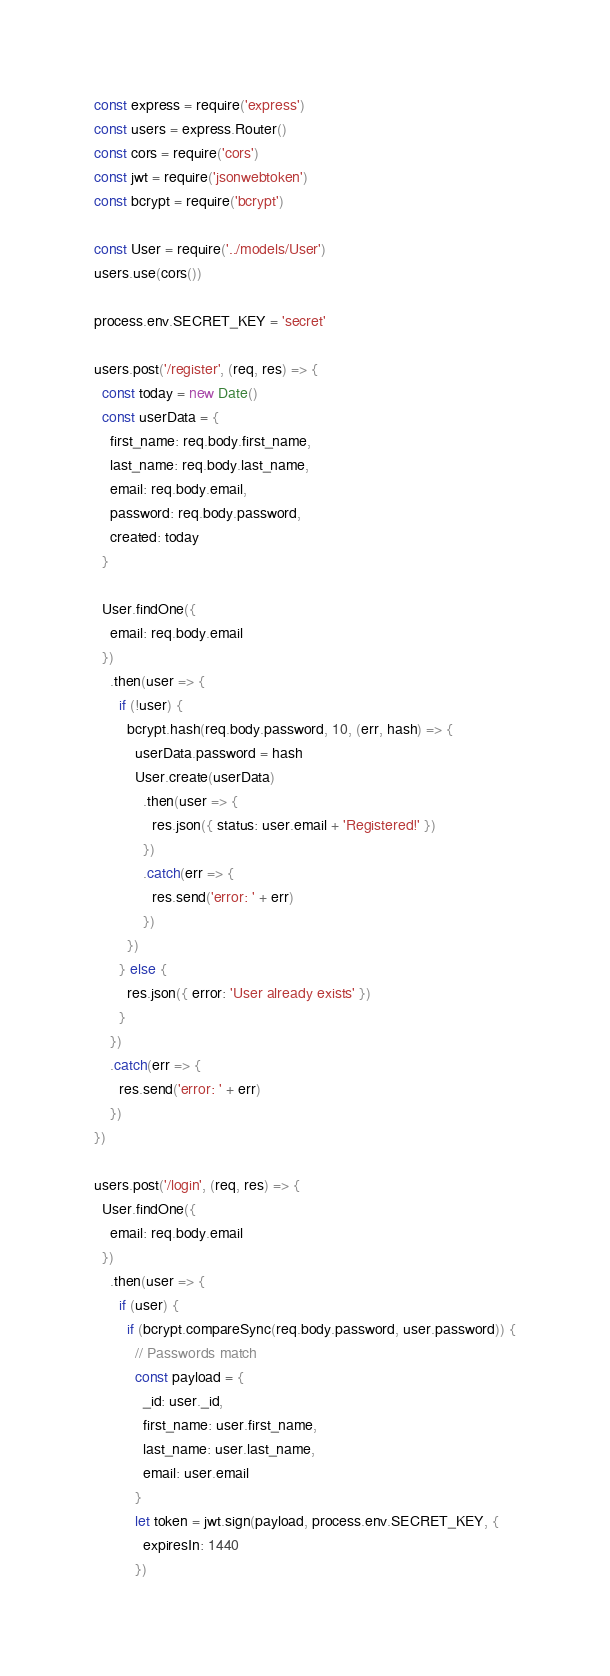Convert code to text. <code><loc_0><loc_0><loc_500><loc_500><_JavaScript_>const express = require('express')
const users = express.Router()
const cors = require('cors')
const jwt = require('jsonwebtoken')
const bcrypt = require('bcrypt')

const User = require('../models/User')
users.use(cors())

process.env.SECRET_KEY = 'secret'

users.post('/register', (req, res) => {
  const today = new Date()
  const userData = {
    first_name: req.body.first_name,
    last_name: req.body.last_name,
    email: req.body.email,
    password: req.body.password,
    created: today
  }

  User.findOne({
    email: req.body.email
  })
    .then(user => {
      if (!user) {
        bcrypt.hash(req.body.password, 10, (err, hash) => {
          userData.password = hash
          User.create(userData)
            .then(user => {
              res.json({ status: user.email + 'Registered!' })
            })
            .catch(err => {
              res.send('error: ' + err)
            })
        })
      } else {
        res.json({ error: 'User already exists' })
      }
    })
    .catch(err => {
      res.send('error: ' + err)
    })
})

users.post('/login', (req, res) => {
  User.findOne({
    email: req.body.email
  })
    .then(user => {
      if (user) {
        if (bcrypt.compareSync(req.body.password, user.password)) {
          // Passwords match
          const payload = {
            _id: user._id,
            first_name: user.first_name,
            last_name: user.last_name,
            email: user.email
          }
          let token = jwt.sign(payload, process.env.SECRET_KEY, {
            expiresIn: 1440
          })</code> 